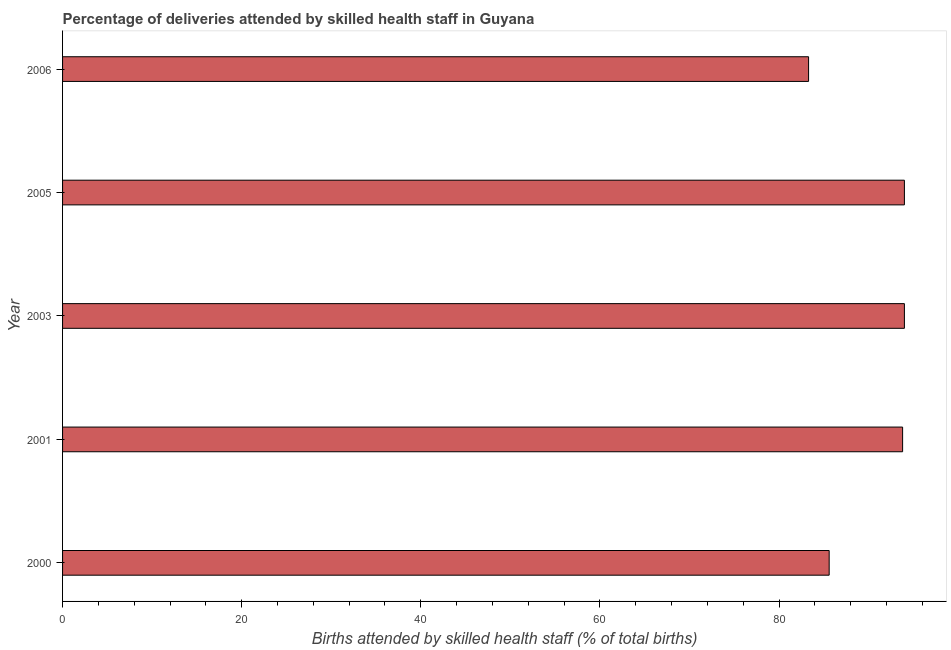Does the graph contain any zero values?
Your answer should be very brief. No. Does the graph contain grids?
Ensure brevity in your answer.  No. What is the title of the graph?
Make the answer very short. Percentage of deliveries attended by skilled health staff in Guyana. What is the label or title of the X-axis?
Keep it short and to the point. Births attended by skilled health staff (% of total births). What is the label or title of the Y-axis?
Offer a terse response. Year. What is the number of births attended by skilled health staff in 2006?
Offer a very short reply. 83.3. Across all years, what is the maximum number of births attended by skilled health staff?
Keep it short and to the point. 94. Across all years, what is the minimum number of births attended by skilled health staff?
Provide a short and direct response. 83.3. In which year was the number of births attended by skilled health staff maximum?
Make the answer very short. 2003. In which year was the number of births attended by skilled health staff minimum?
Offer a very short reply. 2006. What is the sum of the number of births attended by skilled health staff?
Your response must be concise. 450.7. What is the average number of births attended by skilled health staff per year?
Your answer should be compact. 90.14. What is the median number of births attended by skilled health staff?
Provide a short and direct response. 93.8. Do a majority of the years between 2003 and 2001 (inclusive) have number of births attended by skilled health staff greater than 64 %?
Make the answer very short. No. What is the ratio of the number of births attended by skilled health staff in 2000 to that in 2005?
Your answer should be very brief. 0.91. Is the difference between the number of births attended by skilled health staff in 2003 and 2006 greater than the difference between any two years?
Your response must be concise. Yes. What is the difference between the highest and the second highest number of births attended by skilled health staff?
Keep it short and to the point. 0. What is the difference between the highest and the lowest number of births attended by skilled health staff?
Keep it short and to the point. 10.7. Are all the bars in the graph horizontal?
Your response must be concise. Yes. How many years are there in the graph?
Keep it short and to the point. 5. Are the values on the major ticks of X-axis written in scientific E-notation?
Offer a terse response. No. What is the Births attended by skilled health staff (% of total births) in 2000?
Your answer should be very brief. 85.6. What is the Births attended by skilled health staff (% of total births) in 2001?
Provide a succinct answer. 93.8. What is the Births attended by skilled health staff (% of total births) of 2003?
Your answer should be very brief. 94. What is the Births attended by skilled health staff (% of total births) in 2005?
Provide a succinct answer. 94. What is the Births attended by skilled health staff (% of total births) in 2006?
Give a very brief answer. 83.3. What is the difference between the Births attended by skilled health staff (% of total births) in 2000 and 2001?
Keep it short and to the point. -8.2. What is the difference between the Births attended by skilled health staff (% of total births) in 2000 and 2003?
Provide a succinct answer. -8.4. What is the difference between the Births attended by skilled health staff (% of total births) in 2001 and 2003?
Offer a terse response. -0.2. What is the difference between the Births attended by skilled health staff (% of total births) in 2001 and 2005?
Your answer should be very brief. -0.2. What is the difference between the Births attended by skilled health staff (% of total births) in 2003 and 2005?
Provide a succinct answer. 0. What is the difference between the Births attended by skilled health staff (% of total births) in 2005 and 2006?
Ensure brevity in your answer.  10.7. What is the ratio of the Births attended by skilled health staff (% of total births) in 2000 to that in 2003?
Offer a very short reply. 0.91. What is the ratio of the Births attended by skilled health staff (% of total births) in 2000 to that in 2005?
Make the answer very short. 0.91. What is the ratio of the Births attended by skilled health staff (% of total births) in 2000 to that in 2006?
Ensure brevity in your answer.  1.03. What is the ratio of the Births attended by skilled health staff (% of total births) in 2001 to that in 2003?
Your response must be concise. 1. What is the ratio of the Births attended by skilled health staff (% of total births) in 2001 to that in 2005?
Make the answer very short. 1. What is the ratio of the Births attended by skilled health staff (% of total births) in 2001 to that in 2006?
Offer a terse response. 1.13. What is the ratio of the Births attended by skilled health staff (% of total births) in 2003 to that in 2006?
Give a very brief answer. 1.13. What is the ratio of the Births attended by skilled health staff (% of total births) in 2005 to that in 2006?
Provide a short and direct response. 1.13. 